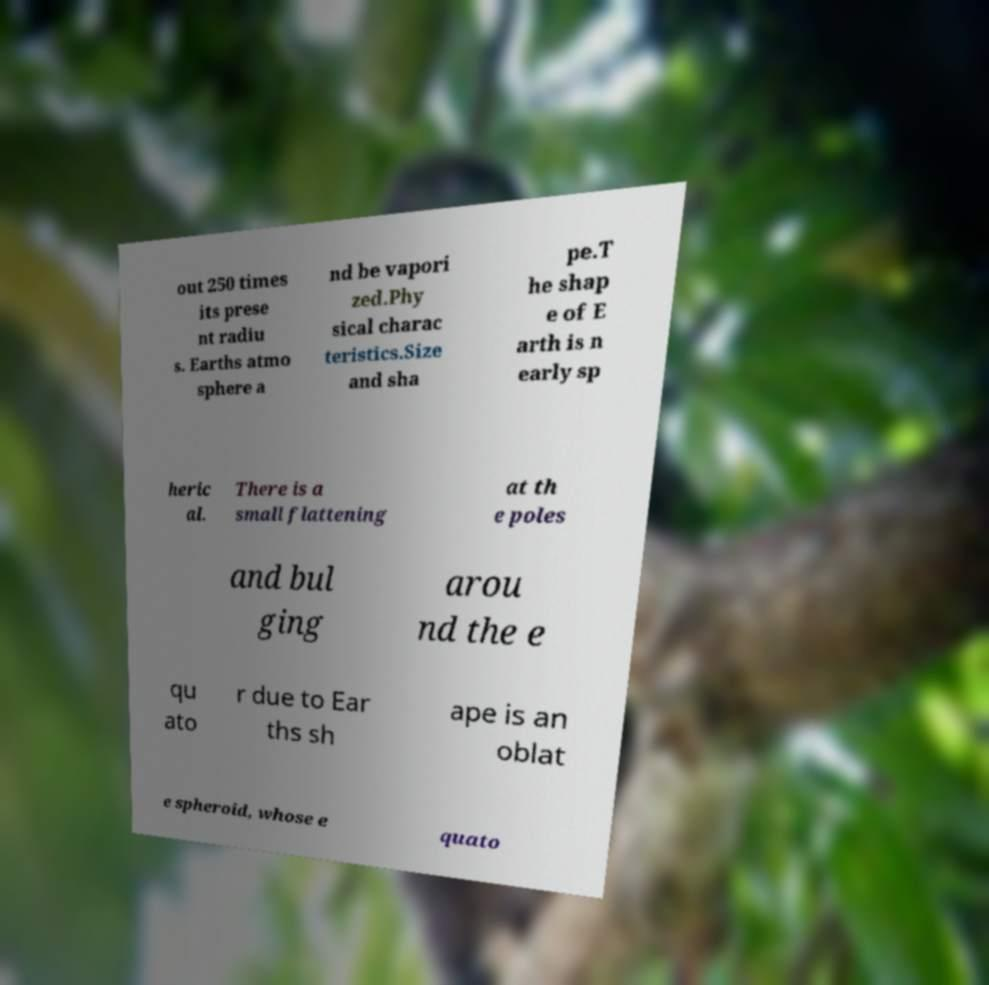For documentation purposes, I need the text within this image transcribed. Could you provide that? out 250 times its prese nt radiu s. Earths atmo sphere a nd be vapori zed.Phy sical charac teristics.Size and sha pe.T he shap e of E arth is n early sp heric al. There is a small flattening at th e poles and bul ging arou nd the e qu ato r due to Ear ths sh ape is an oblat e spheroid, whose e quato 